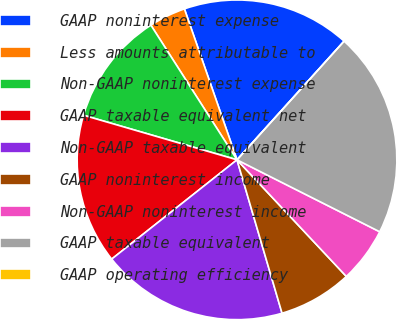Convert chart to OTSL. <chart><loc_0><loc_0><loc_500><loc_500><pie_chart><fcel>GAAP noninterest expense<fcel>Less amounts attributable to<fcel>Non-GAAP noninterest expense<fcel>GAAP taxable equivalent net<fcel>Non-GAAP taxable equivalent<fcel>GAAP noninterest income<fcel>Non-GAAP noninterest income<fcel>GAAP taxable equivalent<fcel>GAAP operating efficiency<nl><fcel>17.02%<fcel>3.72%<fcel>11.44%<fcel>15.16%<fcel>18.88%<fcel>7.44%<fcel>5.58%<fcel>20.74%<fcel>0.0%<nl></chart> 